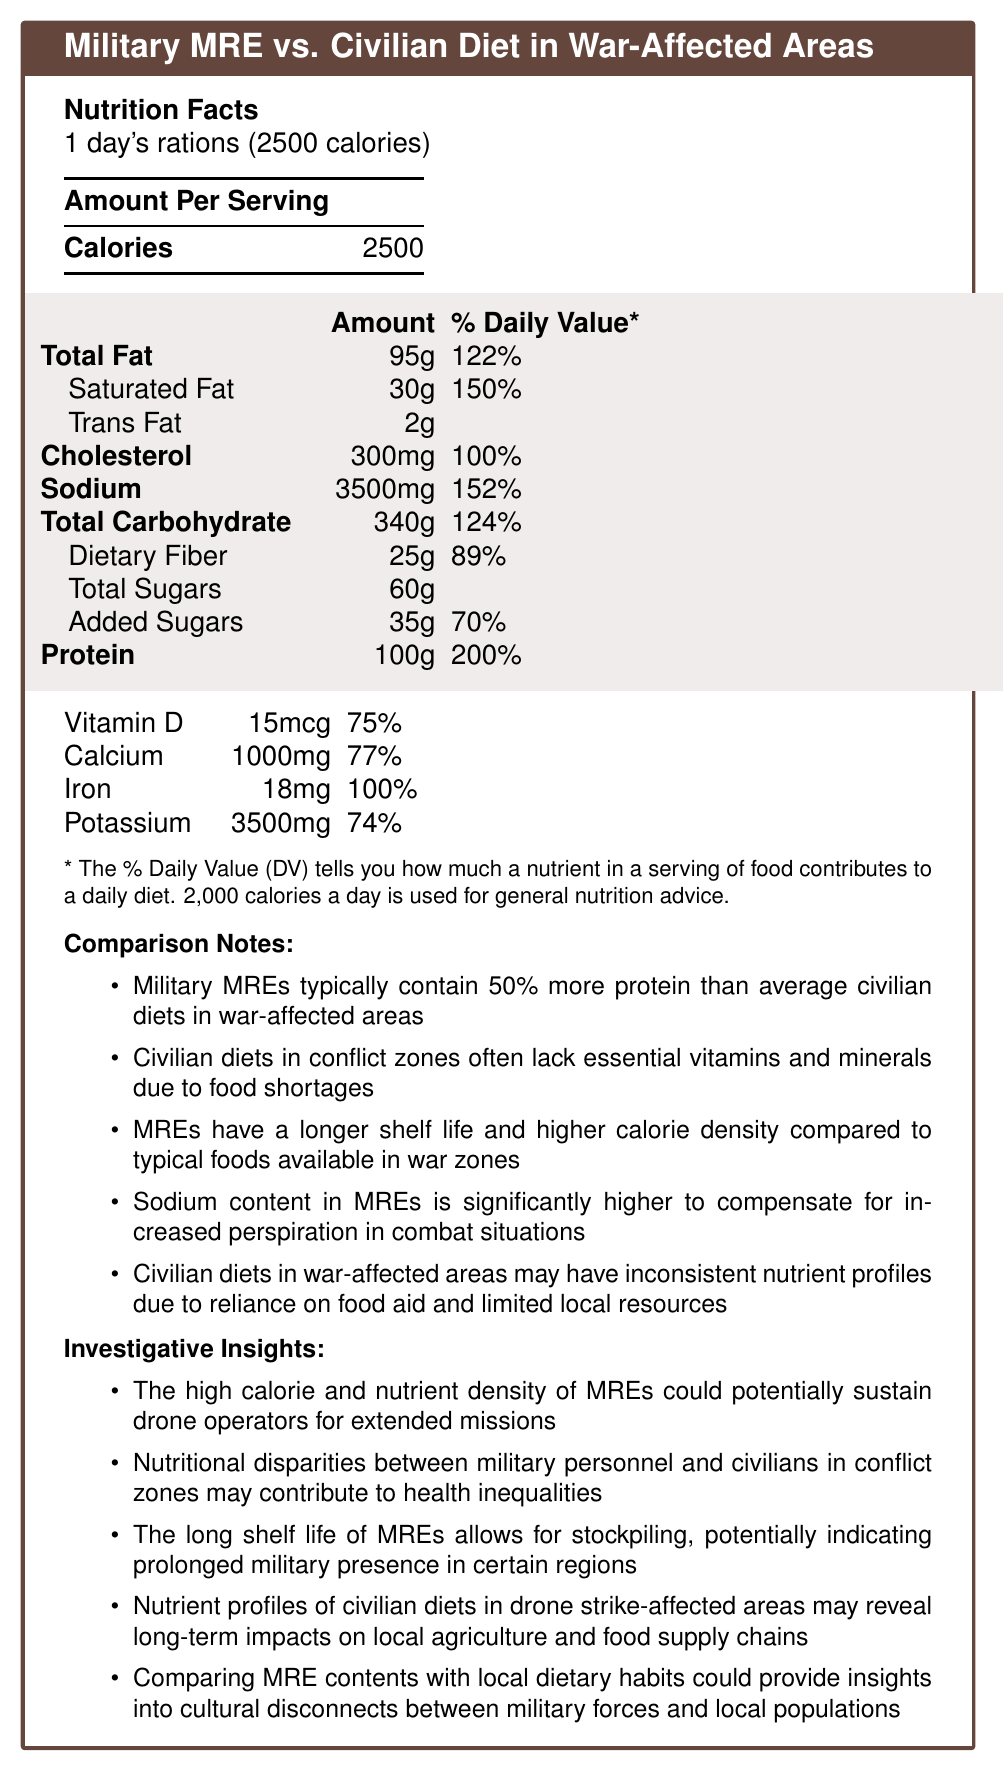what is the serving size for the Military MRE vs. Civilian Diet in War-Affected Areas? The document specifically states that the serving size is "1 day's rations (2500 calories)."
Answer: 1 day's rations (2500 calories) how much total fat does the Military MRE contain per serving? The Nutrition Facts section of the document lists total fat as 95 grams per serving.
Answer: 95g what is the daily value percentage for sodium in the Military MRE? According to the Nutrition Facts, the daily value percentage for sodium is indicated as 152%.
Answer: 152% how much protein is provided in one day's ration of Military MREs? The Nutrition Facts chart lists protein content as 100 grams per serving.
Answer: 100g what is the breakdown of dietary fiber in the total carbohydrate content? The document specifies that the dietary fiber in the total carbohydrate content is 25 grams, which equals 89% of the daily value.
Answer: 25g, 89% which of the following is a correct statement based on the document? A. Sodium content in MREs is lower than civilian diets B. MREs have a higher protein content compared to civilian diets in war zones C. MREs contain less fat than civilian diets The comparison notes mention that Military MREs typically contain 50% more protein than average civilian diets in war-affected areas.
Answer: B what percentage of daily value does calcium contribute in the Military MRE? A. 50% B. 65% C. 77% D. 89% The document specifies that the daily value percentage for calcium is 77%.
Answer: C is it true that the long shelf life of MREs allows for stockpiling? The investigative insights section explicitly states that the long shelf life of MREs allows for stockpiling.
Answer: Yes which nutrient is designed to offset increased perspiration in combat situations? According to the comparison notes, the sodium content in MREs is significantly higher to compensate for increased perspiration in combat situations.
Answer: Sodium describe the main idea of the document. The document provides a detailed analysis of the nutritional content of military MREs and civilian diets in conflict zones. It includes nutrient breakdowns, daily value percentages, and special notes on high protein and sodium content in MREs. Additionally, it offers investigative insights on how these differences affect health disparities and operational logistics in war-affected areas.
Answer: The document compares the nutrient profiles of military MREs with civilian diets in war-affected areas, highlighting differences in calorie content, protein, vitamins, and minerals, as well as discussing the broader implications of these differences on health, military strategy, and local food supply chains. what can be the potential long-term effect of the nutrient profiles of civilian diets in drone strike-affected areas? The document suggests that nutrient profiles of civilian diets in drone strike-affected areas may reveal long-term impacts on local agriculture and food supply chains, but it does not provide detailed information on what those specific long-term effects might be.
Answer: Not enough information 